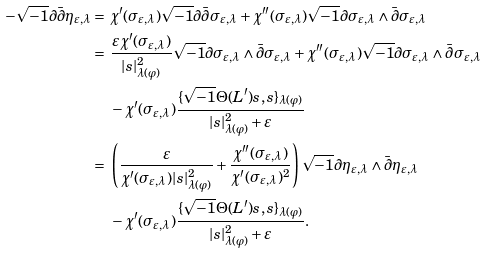<formula> <loc_0><loc_0><loc_500><loc_500>- \sqrt { - 1 } \partial \bar { \partial } \eta _ { \varepsilon , \lambda } = & \ \chi ^ { \prime } ( \sigma _ { \varepsilon , \lambda } ) \sqrt { - 1 } \partial \bar { \partial } \sigma _ { \varepsilon , \lambda } + \chi ^ { \prime \prime } ( \sigma _ { \varepsilon , \lambda } ) \sqrt { - 1 } \partial \sigma _ { \varepsilon , \lambda } \wedge \bar { \partial } \sigma _ { \varepsilon , \lambda } \\ = & \ \frac { \varepsilon \chi ^ { \prime } ( \sigma _ { \varepsilon , \lambda } ) } { | s | ^ { 2 } _ { \lambda ( \varphi ) } } \sqrt { - 1 } \partial \sigma _ { \varepsilon , \lambda } \wedge \bar { \partial } \sigma _ { \varepsilon , \lambda } + \chi ^ { \prime \prime } ( \sigma _ { \varepsilon , \lambda } ) \sqrt { - 1 } \partial \sigma _ { \varepsilon , \lambda } \wedge \bar { \partial } \sigma _ { \varepsilon , \lambda } \\ & \ - \chi ^ { \prime } ( \sigma _ { \varepsilon , \lambda } ) \frac { \{ \sqrt { - 1 } \Theta ( L ^ { \prime } ) s , s \} _ { \lambda ( \varphi ) } } { | s | ^ { 2 } _ { \lambda ( \varphi ) } + \varepsilon } \\ = & \ \left ( \frac { \varepsilon } { \chi ^ { \prime } ( \sigma _ { \varepsilon , \lambda } ) | s | ^ { 2 } _ { \lambda ( \varphi ) } } + \frac { \chi ^ { \prime \prime } ( \sigma _ { \varepsilon , \lambda } ) } { \chi ^ { \prime } ( \sigma _ { \varepsilon , \lambda } ) ^ { 2 } } \right ) \sqrt { - 1 } \partial \eta _ { \varepsilon , \lambda } \wedge \bar { \partial } \eta _ { \varepsilon , \lambda } \\ & \ - \chi ^ { \prime } ( \sigma _ { \varepsilon , \lambda } ) \frac { \{ \sqrt { - 1 } \Theta ( L ^ { \prime } ) s , s \} _ { \lambda ( \varphi ) } } { | s | ^ { 2 } _ { \lambda ( \varphi ) } + \varepsilon } .</formula> 